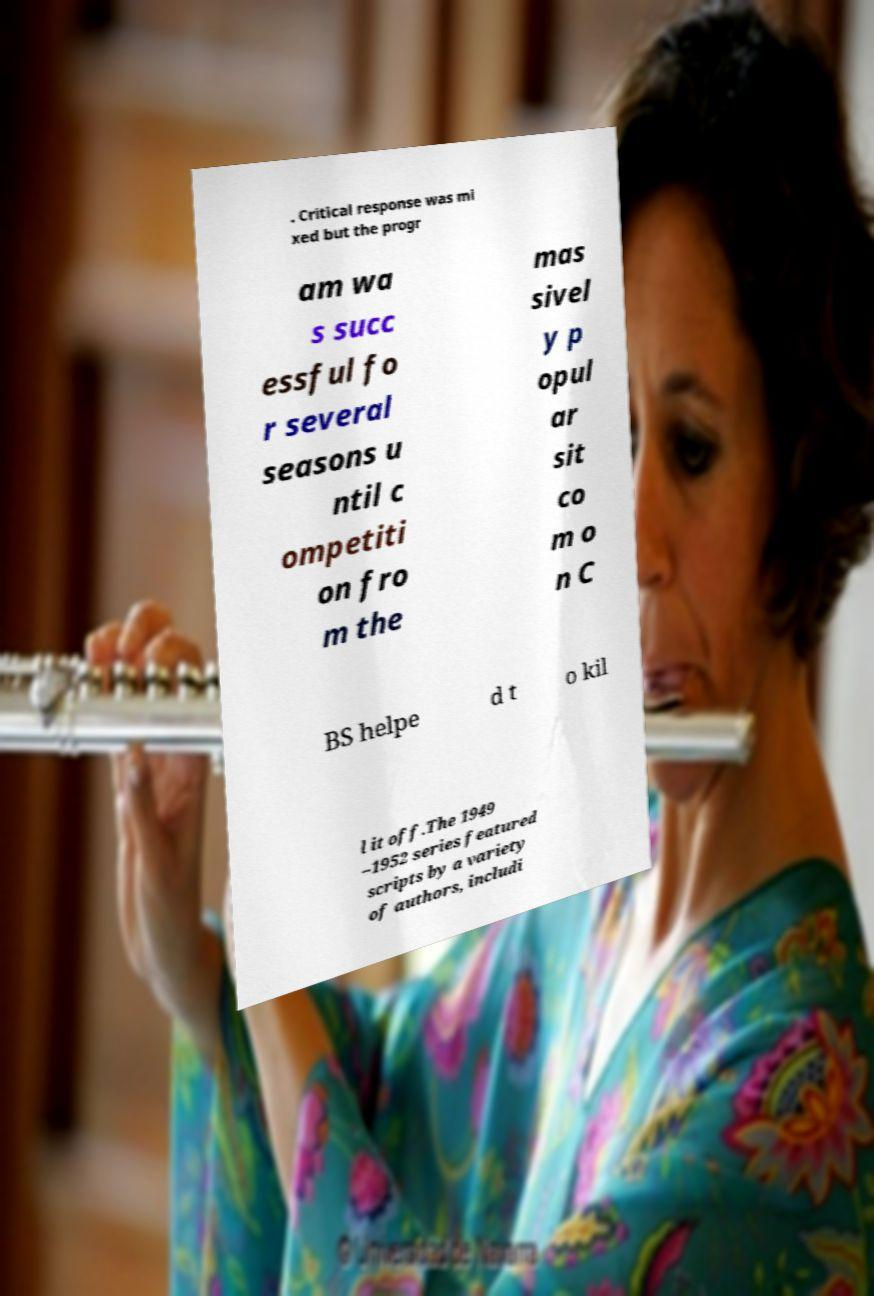For documentation purposes, I need the text within this image transcribed. Could you provide that? . Critical response was mi xed but the progr am wa s succ essful fo r several seasons u ntil c ompetiti on fro m the mas sivel y p opul ar sit co m o n C BS helpe d t o kil l it off.The 1949 –1952 series featured scripts by a variety of authors, includi 